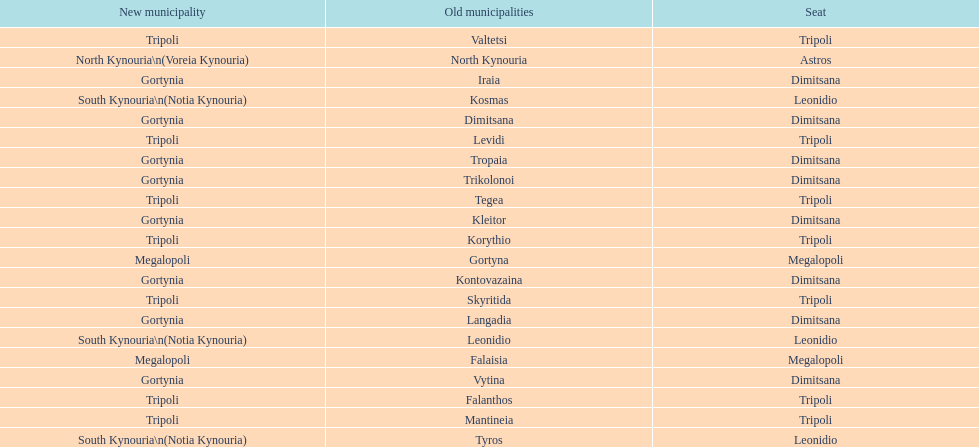When arcadia was reformed in 2011, how many municipalities were created? 5. 